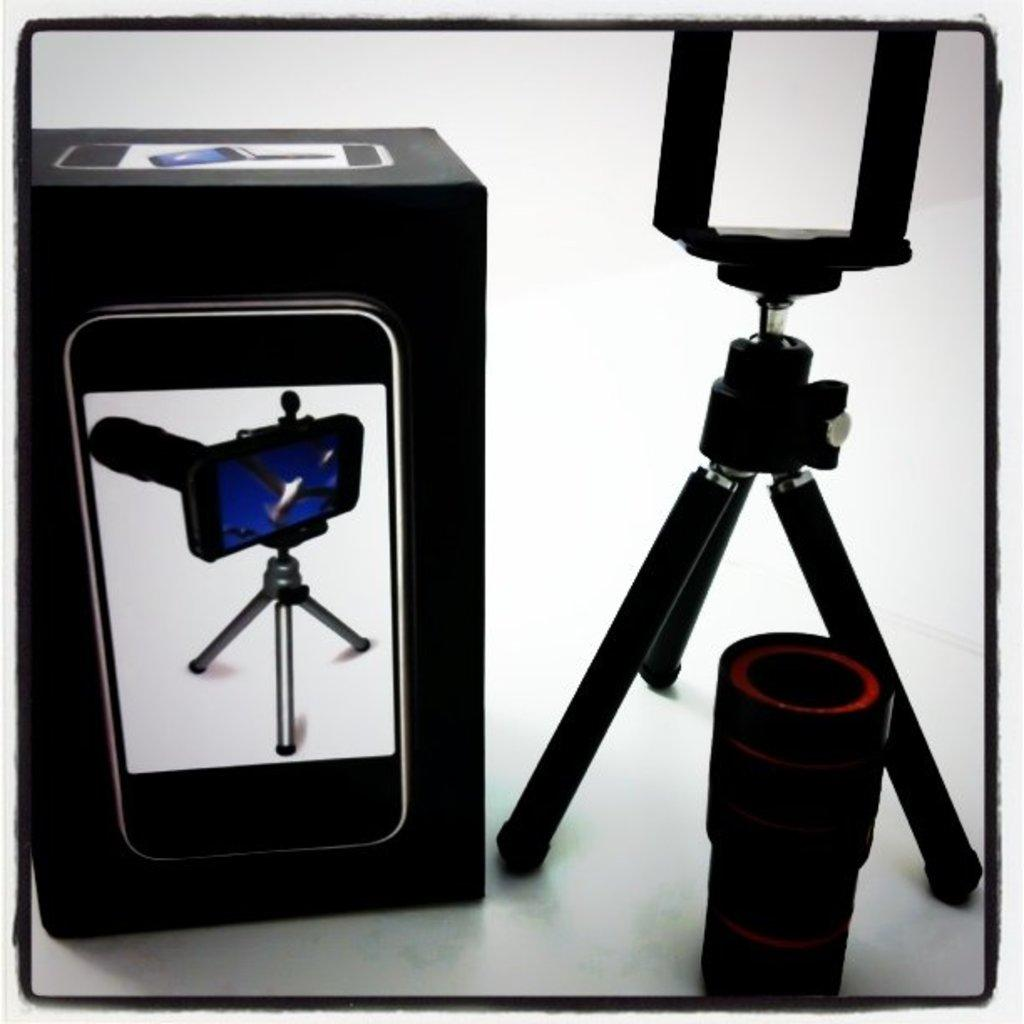What is located on the right side of the image? There is a tripod stand on the right side of the image. What is on the left side of the image? There is a box of a tripod stand on the left side of the image. What color is the background of the image? The background of the image is white. What type of wool is being used to create a nest in the image? There is no wool or nest present in the image; it features a tripod stand and its box. How many ants can be seen crawling on the tripod stand in the image? There are no ants present in the image. 